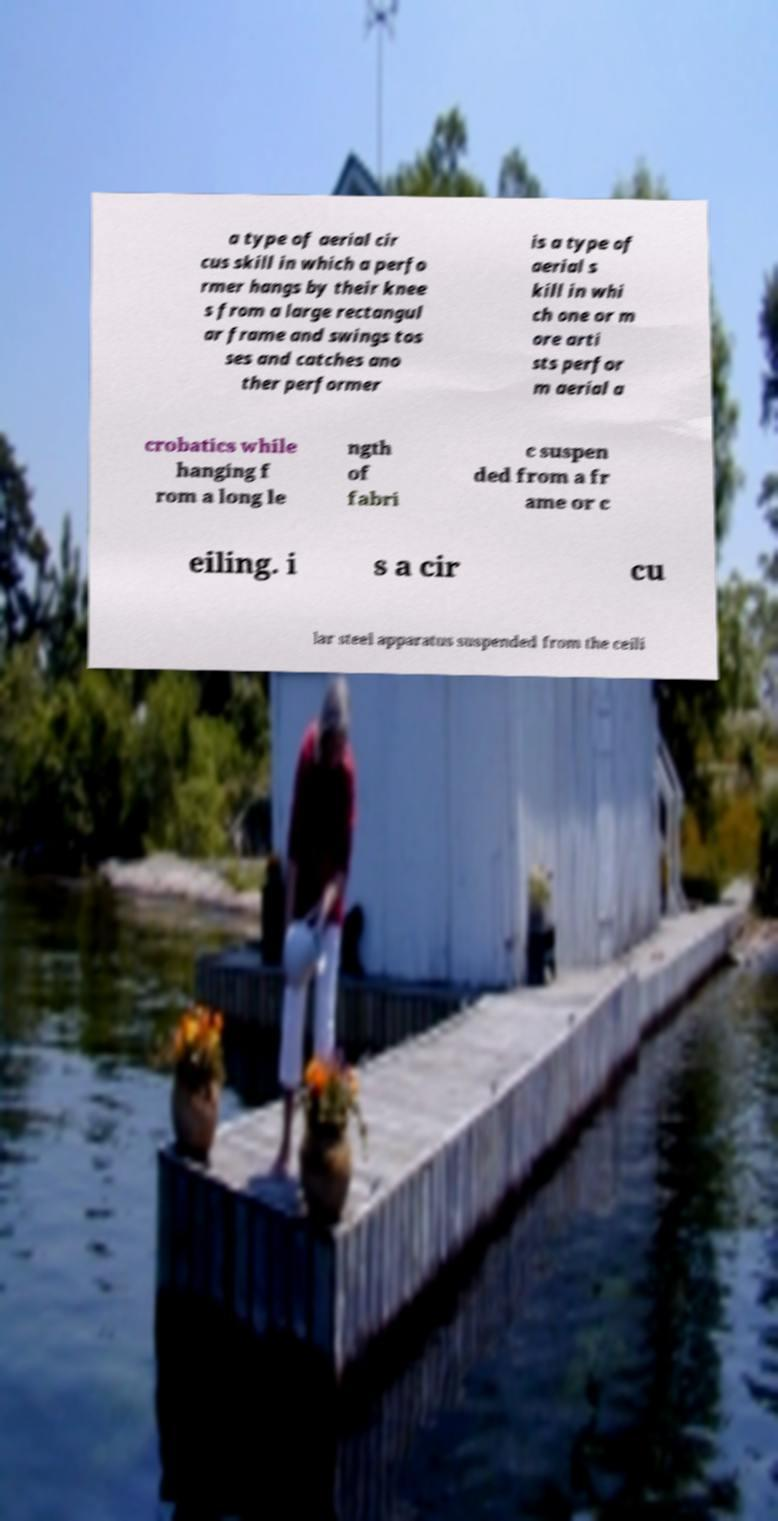Please identify and transcribe the text found in this image. a type of aerial cir cus skill in which a perfo rmer hangs by their knee s from a large rectangul ar frame and swings tos ses and catches ano ther performer is a type of aerial s kill in whi ch one or m ore arti sts perfor m aerial a crobatics while hanging f rom a long le ngth of fabri c suspen ded from a fr ame or c eiling. i s a cir cu lar steel apparatus suspended from the ceili 